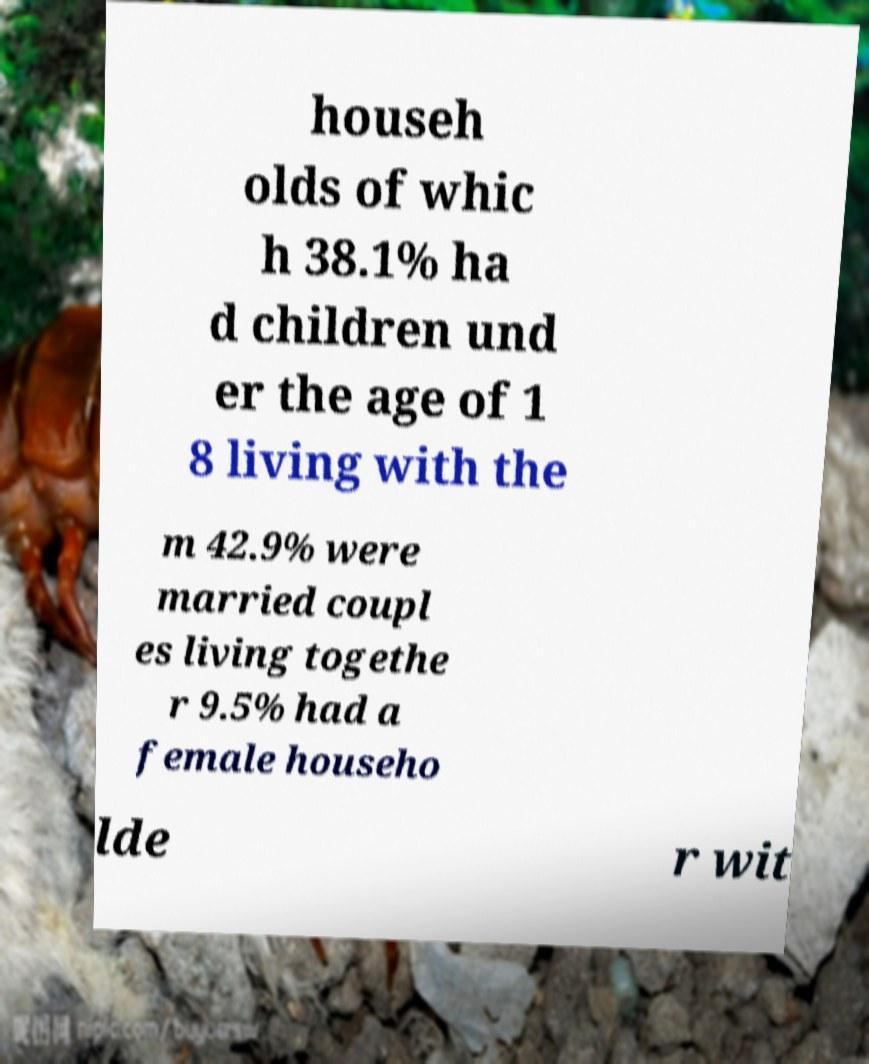I need the written content from this picture converted into text. Can you do that? househ olds of whic h 38.1% ha d children und er the age of 1 8 living with the m 42.9% were married coupl es living togethe r 9.5% had a female househo lde r wit 